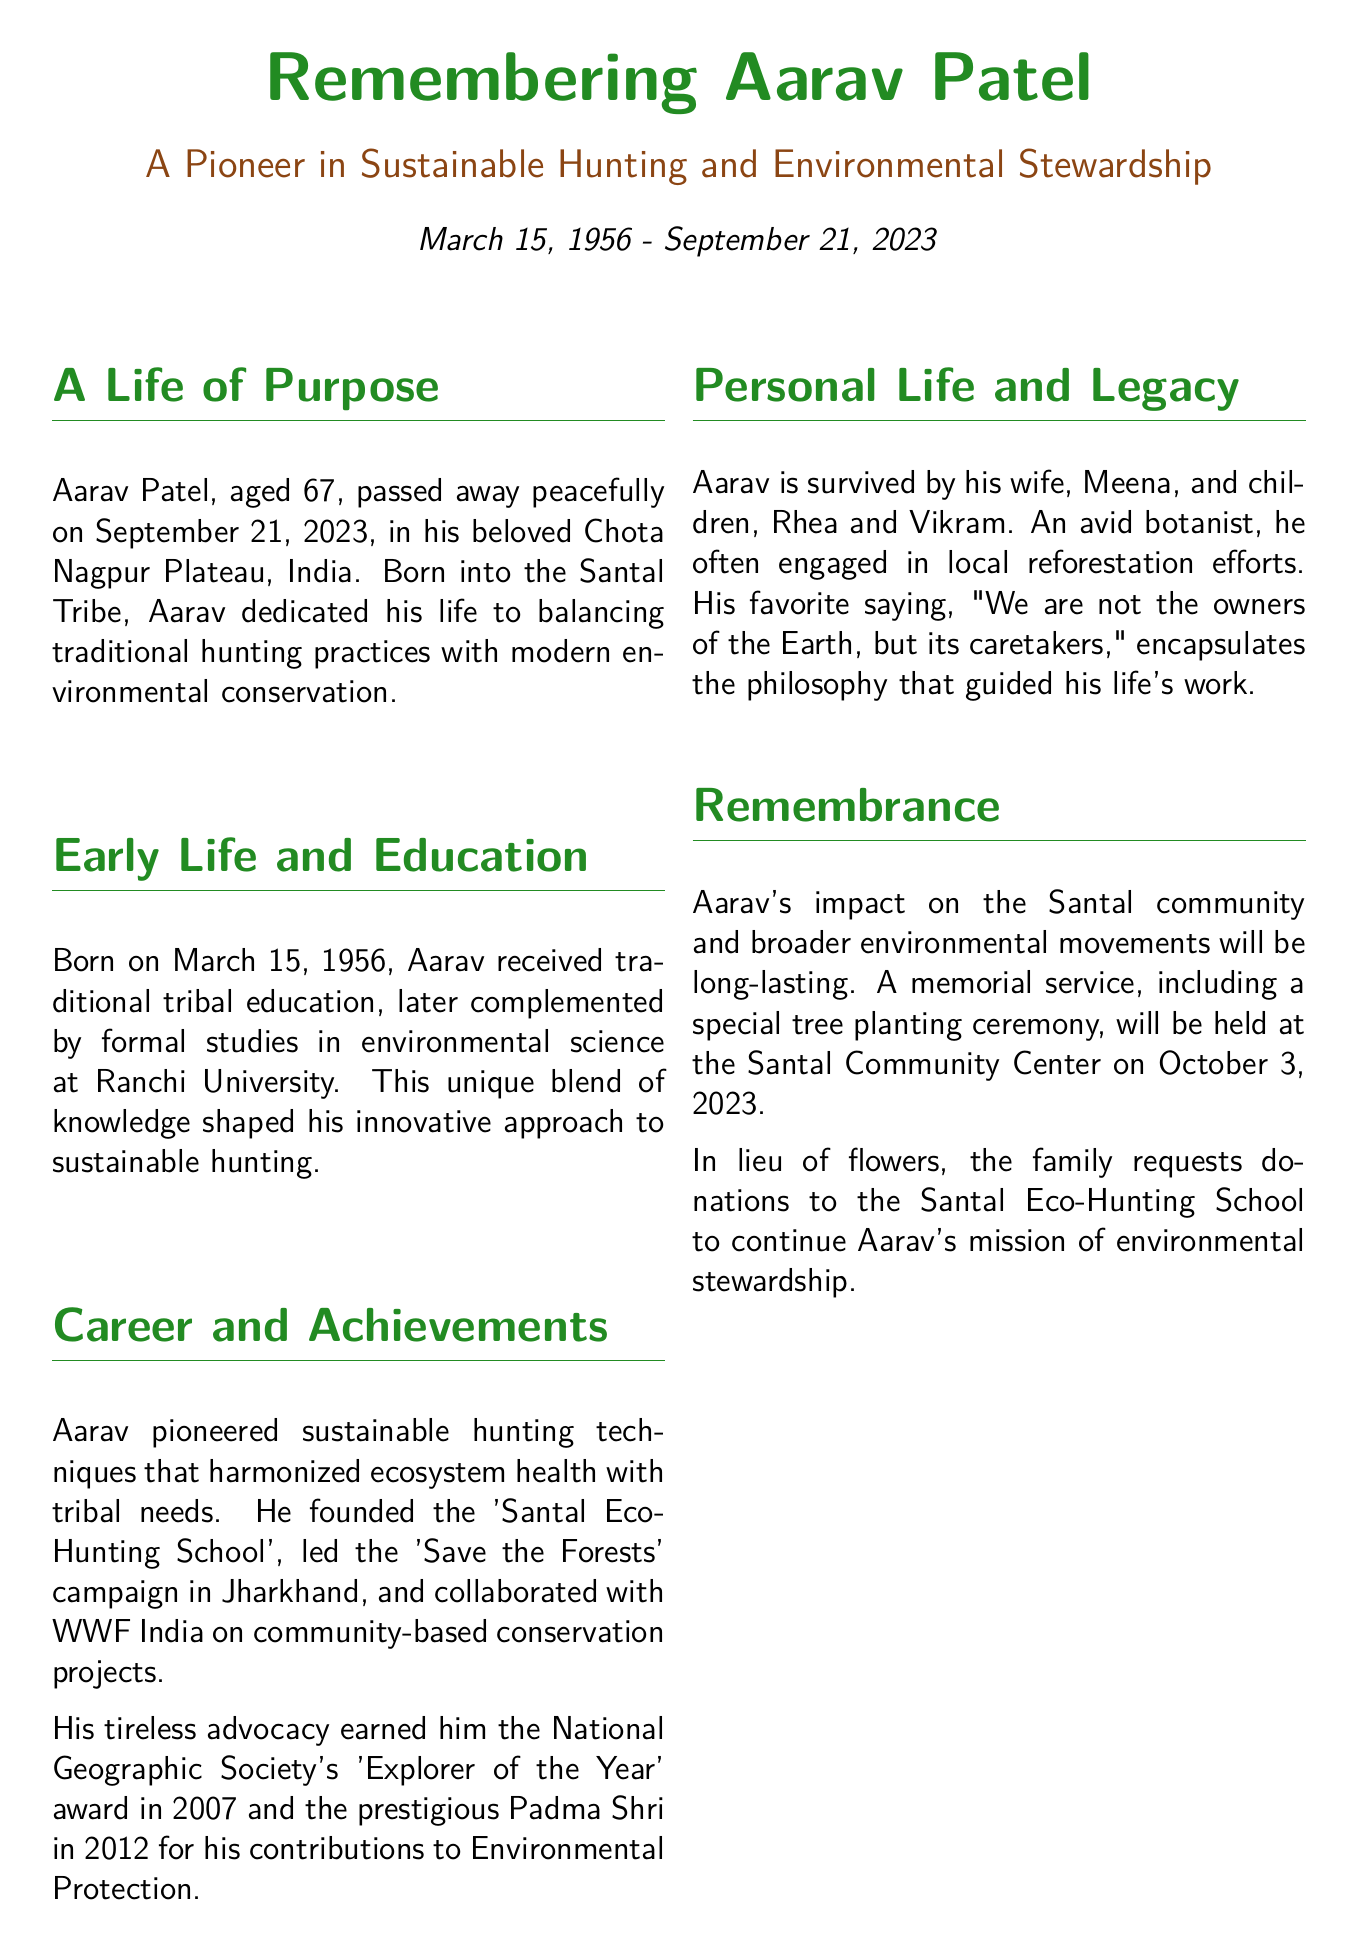What is the full name of the pioneer? The document provides the full name of the pioneer, which is Aarav Patel.
Answer: Aarav Patel What was Aarav's age at the time of his passing? The document mentions that Aarav was aged 67 when he passed away.
Answer: 67 In which year did Aarav win the National Geographic Society's award? The document states he received the 'Explorer of the Year' award in 2007.
Answer: 2007 What is the name of Aarav's wife? The document provides the name of Aarav's wife, who is Meena.
Answer: Meena What was the name of the school Aarav founded? The document states he founded the 'Santal Eco-Hunting School.'
Answer: Santal Eco-Hunting School What is the date of the memorial service? The document specifies that the memorial service will be held on October 3, 2023.
Answer: October 3, 2023 What was Aarav's favorite saying? The document provides his favorite saying, which discusses stewardship of the Earth.
Answer: "We are not the owners of the Earth, but its caretakers." How did Aarav contribute to the local environment? The document mentions that he engaged in local reforestation efforts as an avid botanist.
Answer: Local reforestation efforts What type of campaign did Aarav lead in Jharkhand? The document states that he led the 'Save the Forests' campaign.
Answer: Save the Forests 